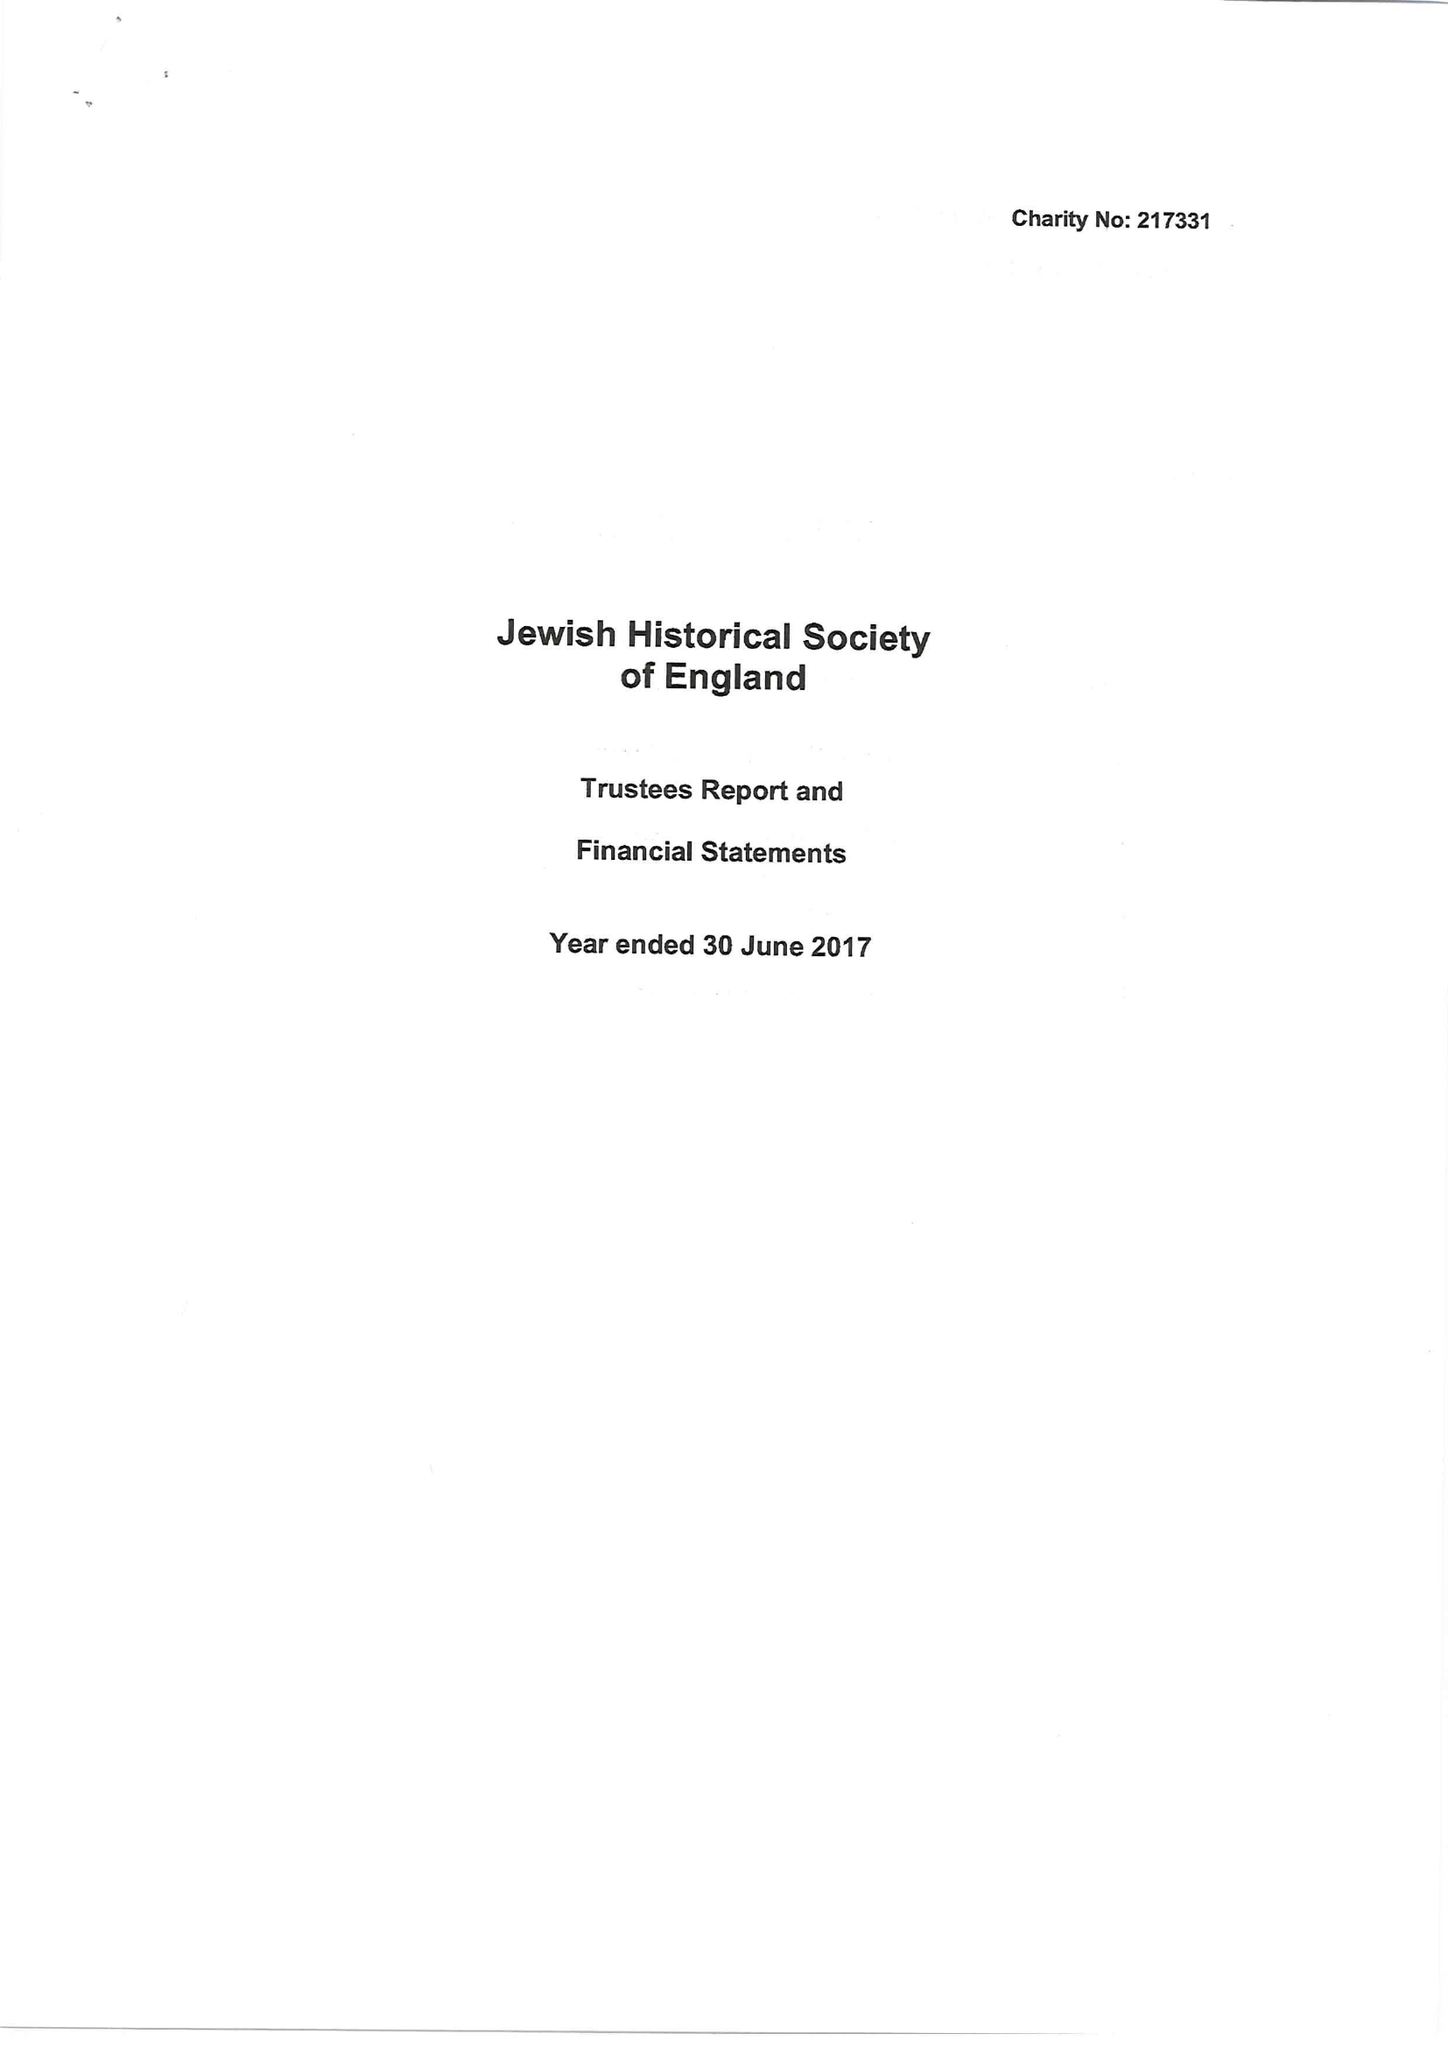What is the value for the report_date?
Answer the question using a single word or phrase. 2017-06-30 